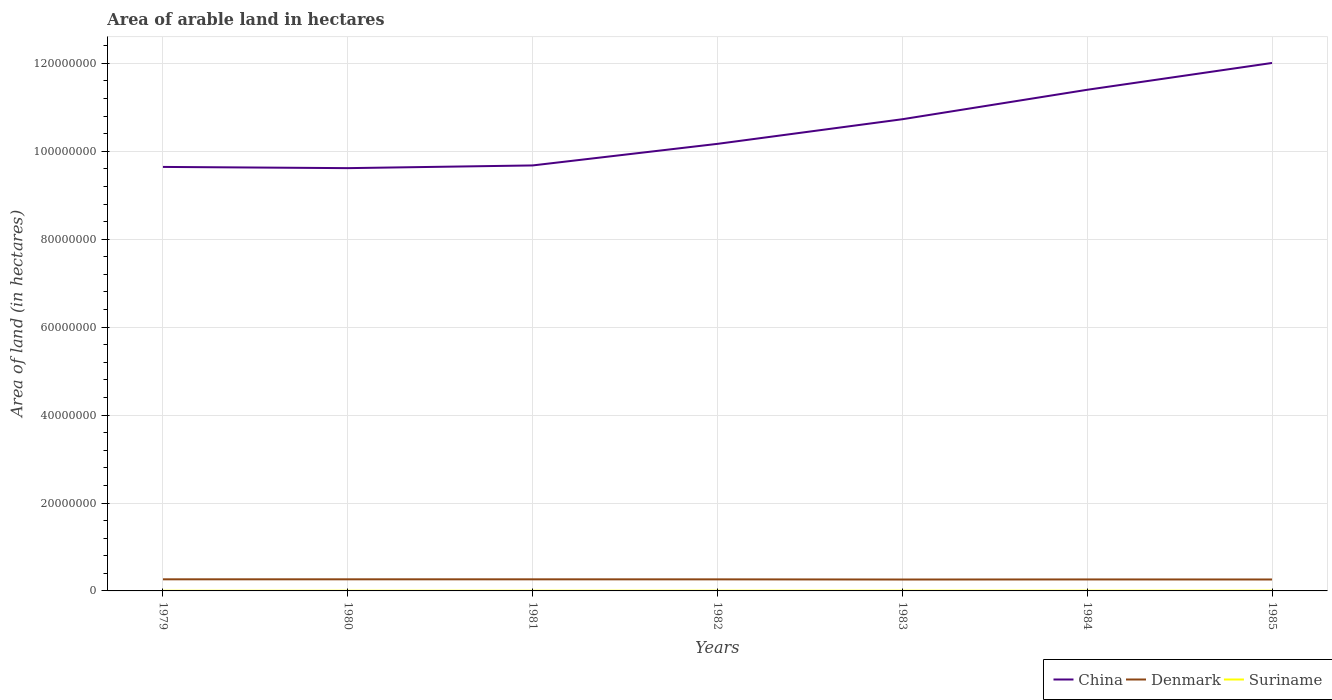How many different coloured lines are there?
Your answer should be very brief. 3. Does the line corresponding to Denmark intersect with the line corresponding to China?
Offer a very short reply. No. Is the number of lines equal to the number of legend labels?
Offer a very short reply. Yes. Across all years, what is the maximum total arable land in China?
Your answer should be very brief. 9.62e+07. What is the total total arable land in Suriname in the graph?
Offer a terse response. -5000. What is the difference between the highest and the second highest total arable land in Suriname?
Your response must be concise. 1.50e+04. Is the total arable land in Denmark strictly greater than the total arable land in Suriname over the years?
Your answer should be very brief. No. Are the values on the major ticks of Y-axis written in scientific E-notation?
Keep it short and to the point. No. Does the graph contain grids?
Provide a succinct answer. Yes. How many legend labels are there?
Offer a terse response. 3. What is the title of the graph?
Provide a short and direct response. Area of arable land in hectares. What is the label or title of the Y-axis?
Offer a terse response. Area of land (in hectares). What is the Area of land (in hectares) in China in 1979?
Provide a succinct answer. 9.65e+07. What is the Area of land (in hectares) of Denmark in 1979?
Your response must be concise. 2.64e+06. What is the Area of land (in hectares) of Suriname in 1979?
Provide a short and direct response. 3.70e+04. What is the Area of land (in hectares) of China in 1980?
Provide a short and direct response. 9.62e+07. What is the Area of land (in hectares) in Denmark in 1980?
Your response must be concise. 2.64e+06. What is the Area of land (in hectares) in China in 1981?
Your response must be concise. 9.68e+07. What is the Area of land (in hectares) of Denmark in 1981?
Give a very brief answer. 2.64e+06. What is the Area of land (in hectares) in Suriname in 1981?
Provide a short and direct response. 4.30e+04. What is the Area of land (in hectares) in China in 1982?
Offer a very short reply. 1.02e+08. What is the Area of land (in hectares) of Denmark in 1982?
Ensure brevity in your answer.  2.63e+06. What is the Area of land (in hectares) of Suriname in 1982?
Offer a very short reply. 4.60e+04. What is the Area of land (in hectares) in China in 1983?
Your answer should be very brief. 1.07e+08. What is the Area of land (in hectares) of Denmark in 1983?
Your answer should be very brief. 2.59e+06. What is the Area of land (in hectares) of Suriname in 1983?
Your answer should be very brief. 4.80e+04. What is the Area of land (in hectares) of China in 1984?
Make the answer very short. 1.14e+08. What is the Area of land (in hectares) in Denmark in 1984?
Provide a short and direct response. 2.61e+06. What is the Area of land (in hectares) of Suriname in 1984?
Offer a very short reply. 5.00e+04. What is the Area of land (in hectares) in China in 1985?
Provide a succinct answer. 1.20e+08. What is the Area of land (in hectares) of Denmark in 1985?
Offer a terse response. 2.60e+06. What is the Area of land (in hectares) of Suriname in 1985?
Offer a very short reply. 5.20e+04. Across all years, what is the maximum Area of land (in hectares) in China?
Give a very brief answer. 1.20e+08. Across all years, what is the maximum Area of land (in hectares) of Denmark?
Give a very brief answer. 2.64e+06. Across all years, what is the maximum Area of land (in hectares) of Suriname?
Your answer should be very brief. 5.20e+04. Across all years, what is the minimum Area of land (in hectares) of China?
Provide a short and direct response. 9.62e+07. Across all years, what is the minimum Area of land (in hectares) of Denmark?
Ensure brevity in your answer.  2.59e+06. Across all years, what is the minimum Area of land (in hectares) in Suriname?
Provide a succinct answer. 3.70e+04. What is the total Area of land (in hectares) in China in the graph?
Ensure brevity in your answer.  7.33e+08. What is the total Area of land (in hectares) of Denmark in the graph?
Provide a succinct answer. 1.84e+07. What is the total Area of land (in hectares) in Suriname in the graph?
Offer a very short reply. 3.16e+05. What is the difference between the Area of land (in hectares) of China in 1979 and that in 1980?
Provide a succinct answer. 2.77e+05. What is the difference between the Area of land (in hectares) in Denmark in 1979 and that in 1980?
Provide a short and direct response. 3000. What is the difference between the Area of land (in hectares) of Suriname in 1979 and that in 1980?
Provide a short and direct response. -3000. What is the difference between the Area of land (in hectares) of China in 1979 and that in 1981?
Provide a succinct answer. -3.38e+05. What is the difference between the Area of land (in hectares) in Denmark in 1979 and that in 1981?
Give a very brief answer. 5000. What is the difference between the Area of land (in hectares) of Suriname in 1979 and that in 1981?
Your answer should be very brief. -6000. What is the difference between the Area of land (in hectares) in China in 1979 and that in 1982?
Ensure brevity in your answer.  -5.25e+06. What is the difference between the Area of land (in hectares) of Denmark in 1979 and that in 1982?
Ensure brevity in your answer.  1.20e+04. What is the difference between the Area of land (in hectares) in Suriname in 1979 and that in 1982?
Offer a terse response. -9000. What is the difference between the Area of land (in hectares) of China in 1979 and that in 1983?
Ensure brevity in your answer.  -1.08e+07. What is the difference between the Area of land (in hectares) in Denmark in 1979 and that in 1983?
Ensure brevity in your answer.  4.90e+04. What is the difference between the Area of land (in hectares) of Suriname in 1979 and that in 1983?
Offer a terse response. -1.10e+04. What is the difference between the Area of land (in hectares) of China in 1979 and that in 1984?
Make the answer very short. -1.75e+07. What is the difference between the Area of land (in hectares) of Suriname in 1979 and that in 1984?
Your response must be concise. -1.30e+04. What is the difference between the Area of land (in hectares) of China in 1979 and that in 1985?
Your answer should be very brief. -2.36e+07. What is the difference between the Area of land (in hectares) of Denmark in 1979 and that in 1985?
Keep it short and to the point. 4.10e+04. What is the difference between the Area of land (in hectares) in Suriname in 1979 and that in 1985?
Give a very brief answer. -1.50e+04. What is the difference between the Area of land (in hectares) in China in 1980 and that in 1981?
Make the answer very short. -6.15e+05. What is the difference between the Area of land (in hectares) in Suriname in 1980 and that in 1981?
Your answer should be very brief. -3000. What is the difference between the Area of land (in hectares) in China in 1980 and that in 1982?
Offer a very short reply. -5.52e+06. What is the difference between the Area of land (in hectares) of Denmark in 1980 and that in 1982?
Provide a succinct answer. 9000. What is the difference between the Area of land (in hectares) in Suriname in 1980 and that in 1982?
Your response must be concise. -6000. What is the difference between the Area of land (in hectares) in China in 1980 and that in 1983?
Keep it short and to the point. -1.11e+07. What is the difference between the Area of land (in hectares) of Denmark in 1980 and that in 1983?
Your answer should be compact. 4.60e+04. What is the difference between the Area of land (in hectares) of Suriname in 1980 and that in 1983?
Keep it short and to the point. -8000. What is the difference between the Area of land (in hectares) in China in 1980 and that in 1984?
Give a very brief answer. -1.78e+07. What is the difference between the Area of land (in hectares) in Denmark in 1980 and that in 1984?
Ensure brevity in your answer.  2.70e+04. What is the difference between the Area of land (in hectares) in China in 1980 and that in 1985?
Offer a very short reply. -2.39e+07. What is the difference between the Area of land (in hectares) in Denmark in 1980 and that in 1985?
Give a very brief answer. 3.80e+04. What is the difference between the Area of land (in hectares) in Suriname in 1980 and that in 1985?
Provide a short and direct response. -1.20e+04. What is the difference between the Area of land (in hectares) of China in 1981 and that in 1982?
Your answer should be very brief. -4.91e+06. What is the difference between the Area of land (in hectares) of Denmark in 1981 and that in 1982?
Your response must be concise. 7000. What is the difference between the Area of land (in hectares) of Suriname in 1981 and that in 1982?
Keep it short and to the point. -3000. What is the difference between the Area of land (in hectares) of China in 1981 and that in 1983?
Your answer should be very brief. -1.05e+07. What is the difference between the Area of land (in hectares) in Denmark in 1981 and that in 1983?
Offer a very short reply. 4.40e+04. What is the difference between the Area of land (in hectares) of Suriname in 1981 and that in 1983?
Your answer should be very brief. -5000. What is the difference between the Area of land (in hectares) of China in 1981 and that in 1984?
Offer a terse response. -1.72e+07. What is the difference between the Area of land (in hectares) of Denmark in 1981 and that in 1984?
Keep it short and to the point. 2.50e+04. What is the difference between the Area of land (in hectares) in Suriname in 1981 and that in 1984?
Offer a very short reply. -7000. What is the difference between the Area of land (in hectares) of China in 1981 and that in 1985?
Keep it short and to the point. -2.33e+07. What is the difference between the Area of land (in hectares) of Denmark in 1981 and that in 1985?
Your answer should be very brief. 3.60e+04. What is the difference between the Area of land (in hectares) of Suriname in 1981 and that in 1985?
Give a very brief answer. -9000. What is the difference between the Area of land (in hectares) in China in 1982 and that in 1983?
Make the answer very short. -5.60e+06. What is the difference between the Area of land (in hectares) in Denmark in 1982 and that in 1983?
Make the answer very short. 3.70e+04. What is the difference between the Area of land (in hectares) in Suriname in 1982 and that in 1983?
Give a very brief answer. -2000. What is the difference between the Area of land (in hectares) in China in 1982 and that in 1984?
Provide a short and direct response. -1.23e+07. What is the difference between the Area of land (in hectares) of Denmark in 1982 and that in 1984?
Offer a terse response. 1.80e+04. What is the difference between the Area of land (in hectares) of Suriname in 1982 and that in 1984?
Ensure brevity in your answer.  -4000. What is the difference between the Area of land (in hectares) in China in 1982 and that in 1985?
Offer a very short reply. -1.84e+07. What is the difference between the Area of land (in hectares) in Denmark in 1982 and that in 1985?
Your response must be concise. 2.90e+04. What is the difference between the Area of land (in hectares) in Suriname in 1982 and that in 1985?
Provide a succinct answer. -6000. What is the difference between the Area of land (in hectares) in China in 1983 and that in 1984?
Give a very brief answer. -6.70e+06. What is the difference between the Area of land (in hectares) in Denmark in 1983 and that in 1984?
Ensure brevity in your answer.  -1.90e+04. What is the difference between the Area of land (in hectares) of Suriname in 1983 and that in 1984?
Give a very brief answer. -2000. What is the difference between the Area of land (in hectares) in China in 1983 and that in 1985?
Make the answer very short. -1.28e+07. What is the difference between the Area of land (in hectares) of Denmark in 1983 and that in 1985?
Make the answer very short. -8000. What is the difference between the Area of land (in hectares) of Suriname in 1983 and that in 1985?
Keep it short and to the point. -4000. What is the difference between the Area of land (in hectares) in China in 1984 and that in 1985?
Ensure brevity in your answer.  -6.10e+06. What is the difference between the Area of land (in hectares) of Denmark in 1984 and that in 1985?
Offer a terse response. 1.10e+04. What is the difference between the Area of land (in hectares) in Suriname in 1984 and that in 1985?
Your response must be concise. -2000. What is the difference between the Area of land (in hectares) of China in 1979 and the Area of land (in hectares) of Denmark in 1980?
Offer a very short reply. 9.38e+07. What is the difference between the Area of land (in hectares) of China in 1979 and the Area of land (in hectares) of Suriname in 1980?
Your response must be concise. 9.64e+07. What is the difference between the Area of land (in hectares) of Denmark in 1979 and the Area of land (in hectares) of Suriname in 1980?
Your answer should be very brief. 2.60e+06. What is the difference between the Area of land (in hectares) in China in 1979 and the Area of land (in hectares) in Denmark in 1981?
Offer a very short reply. 9.38e+07. What is the difference between the Area of land (in hectares) of China in 1979 and the Area of land (in hectares) of Suriname in 1981?
Make the answer very short. 9.64e+07. What is the difference between the Area of land (in hectares) of Denmark in 1979 and the Area of land (in hectares) of Suriname in 1981?
Ensure brevity in your answer.  2.60e+06. What is the difference between the Area of land (in hectares) of China in 1979 and the Area of land (in hectares) of Denmark in 1982?
Provide a short and direct response. 9.38e+07. What is the difference between the Area of land (in hectares) of China in 1979 and the Area of land (in hectares) of Suriname in 1982?
Make the answer very short. 9.64e+07. What is the difference between the Area of land (in hectares) of Denmark in 1979 and the Area of land (in hectares) of Suriname in 1982?
Provide a short and direct response. 2.60e+06. What is the difference between the Area of land (in hectares) of China in 1979 and the Area of land (in hectares) of Denmark in 1983?
Make the answer very short. 9.39e+07. What is the difference between the Area of land (in hectares) of China in 1979 and the Area of land (in hectares) of Suriname in 1983?
Your response must be concise. 9.64e+07. What is the difference between the Area of land (in hectares) in Denmark in 1979 and the Area of land (in hectares) in Suriname in 1983?
Offer a very short reply. 2.59e+06. What is the difference between the Area of land (in hectares) in China in 1979 and the Area of land (in hectares) in Denmark in 1984?
Offer a very short reply. 9.38e+07. What is the difference between the Area of land (in hectares) in China in 1979 and the Area of land (in hectares) in Suriname in 1984?
Offer a terse response. 9.64e+07. What is the difference between the Area of land (in hectares) of Denmark in 1979 and the Area of land (in hectares) of Suriname in 1984?
Provide a succinct answer. 2.59e+06. What is the difference between the Area of land (in hectares) of China in 1979 and the Area of land (in hectares) of Denmark in 1985?
Keep it short and to the point. 9.39e+07. What is the difference between the Area of land (in hectares) of China in 1979 and the Area of land (in hectares) of Suriname in 1985?
Keep it short and to the point. 9.64e+07. What is the difference between the Area of land (in hectares) of Denmark in 1979 and the Area of land (in hectares) of Suriname in 1985?
Provide a short and direct response. 2.59e+06. What is the difference between the Area of land (in hectares) of China in 1980 and the Area of land (in hectares) of Denmark in 1981?
Make the answer very short. 9.35e+07. What is the difference between the Area of land (in hectares) of China in 1980 and the Area of land (in hectares) of Suriname in 1981?
Your answer should be compact. 9.61e+07. What is the difference between the Area of land (in hectares) of Denmark in 1980 and the Area of land (in hectares) of Suriname in 1981?
Offer a terse response. 2.60e+06. What is the difference between the Area of land (in hectares) of China in 1980 and the Area of land (in hectares) of Denmark in 1982?
Your response must be concise. 9.35e+07. What is the difference between the Area of land (in hectares) in China in 1980 and the Area of land (in hectares) in Suriname in 1982?
Keep it short and to the point. 9.61e+07. What is the difference between the Area of land (in hectares) of Denmark in 1980 and the Area of land (in hectares) of Suriname in 1982?
Give a very brief answer. 2.59e+06. What is the difference between the Area of land (in hectares) in China in 1980 and the Area of land (in hectares) in Denmark in 1983?
Keep it short and to the point. 9.36e+07. What is the difference between the Area of land (in hectares) of China in 1980 and the Area of land (in hectares) of Suriname in 1983?
Offer a terse response. 9.61e+07. What is the difference between the Area of land (in hectares) in Denmark in 1980 and the Area of land (in hectares) in Suriname in 1983?
Give a very brief answer. 2.59e+06. What is the difference between the Area of land (in hectares) in China in 1980 and the Area of land (in hectares) in Denmark in 1984?
Keep it short and to the point. 9.36e+07. What is the difference between the Area of land (in hectares) of China in 1980 and the Area of land (in hectares) of Suriname in 1984?
Ensure brevity in your answer.  9.61e+07. What is the difference between the Area of land (in hectares) in Denmark in 1980 and the Area of land (in hectares) in Suriname in 1984?
Keep it short and to the point. 2.59e+06. What is the difference between the Area of land (in hectares) in China in 1980 and the Area of land (in hectares) in Denmark in 1985?
Offer a very short reply. 9.36e+07. What is the difference between the Area of land (in hectares) in China in 1980 and the Area of land (in hectares) in Suriname in 1985?
Provide a short and direct response. 9.61e+07. What is the difference between the Area of land (in hectares) of Denmark in 1980 and the Area of land (in hectares) of Suriname in 1985?
Offer a terse response. 2.59e+06. What is the difference between the Area of land (in hectares) of China in 1981 and the Area of land (in hectares) of Denmark in 1982?
Provide a succinct answer. 9.42e+07. What is the difference between the Area of land (in hectares) in China in 1981 and the Area of land (in hectares) in Suriname in 1982?
Keep it short and to the point. 9.67e+07. What is the difference between the Area of land (in hectares) of Denmark in 1981 and the Area of land (in hectares) of Suriname in 1982?
Your answer should be very brief. 2.59e+06. What is the difference between the Area of land (in hectares) of China in 1981 and the Area of land (in hectares) of Denmark in 1983?
Keep it short and to the point. 9.42e+07. What is the difference between the Area of land (in hectares) in China in 1981 and the Area of land (in hectares) in Suriname in 1983?
Your response must be concise. 9.67e+07. What is the difference between the Area of land (in hectares) in Denmark in 1981 and the Area of land (in hectares) in Suriname in 1983?
Provide a succinct answer. 2.59e+06. What is the difference between the Area of land (in hectares) of China in 1981 and the Area of land (in hectares) of Denmark in 1984?
Offer a terse response. 9.42e+07. What is the difference between the Area of land (in hectares) of China in 1981 and the Area of land (in hectares) of Suriname in 1984?
Give a very brief answer. 9.67e+07. What is the difference between the Area of land (in hectares) in Denmark in 1981 and the Area of land (in hectares) in Suriname in 1984?
Provide a short and direct response. 2.59e+06. What is the difference between the Area of land (in hectares) in China in 1981 and the Area of land (in hectares) in Denmark in 1985?
Provide a succinct answer. 9.42e+07. What is the difference between the Area of land (in hectares) in China in 1981 and the Area of land (in hectares) in Suriname in 1985?
Keep it short and to the point. 9.67e+07. What is the difference between the Area of land (in hectares) of Denmark in 1981 and the Area of land (in hectares) of Suriname in 1985?
Your answer should be compact. 2.58e+06. What is the difference between the Area of land (in hectares) of China in 1982 and the Area of land (in hectares) of Denmark in 1983?
Your response must be concise. 9.91e+07. What is the difference between the Area of land (in hectares) in China in 1982 and the Area of land (in hectares) in Suriname in 1983?
Give a very brief answer. 1.02e+08. What is the difference between the Area of land (in hectares) in Denmark in 1982 and the Area of land (in hectares) in Suriname in 1983?
Your answer should be very brief. 2.58e+06. What is the difference between the Area of land (in hectares) of China in 1982 and the Area of land (in hectares) of Denmark in 1984?
Give a very brief answer. 9.91e+07. What is the difference between the Area of land (in hectares) of China in 1982 and the Area of land (in hectares) of Suriname in 1984?
Make the answer very short. 1.02e+08. What is the difference between the Area of land (in hectares) in Denmark in 1982 and the Area of land (in hectares) in Suriname in 1984?
Offer a terse response. 2.58e+06. What is the difference between the Area of land (in hectares) of China in 1982 and the Area of land (in hectares) of Denmark in 1985?
Give a very brief answer. 9.91e+07. What is the difference between the Area of land (in hectares) in China in 1982 and the Area of land (in hectares) in Suriname in 1985?
Give a very brief answer. 1.02e+08. What is the difference between the Area of land (in hectares) of Denmark in 1982 and the Area of land (in hectares) of Suriname in 1985?
Offer a terse response. 2.58e+06. What is the difference between the Area of land (in hectares) in China in 1983 and the Area of land (in hectares) in Denmark in 1984?
Ensure brevity in your answer.  1.05e+08. What is the difference between the Area of land (in hectares) of China in 1983 and the Area of land (in hectares) of Suriname in 1984?
Offer a terse response. 1.07e+08. What is the difference between the Area of land (in hectares) of Denmark in 1983 and the Area of land (in hectares) of Suriname in 1984?
Your answer should be very brief. 2.54e+06. What is the difference between the Area of land (in hectares) in China in 1983 and the Area of land (in hectares) in Denmark in 1985?
Give a very brief answer. 1.05e+08. What is the difference between the Area of land (in hectares) in China in 1983 and the Area of land (in hectares) in Suriname in 1985?
Your response must be concise. 1.07e+08. What is the difference between the Area of land (in hectares) of Denmark in 1983 and the Area of land (in hectares) of Suriname in 1985?
Your answer should be very brief. 2.54e+06. What is the difference between the Area of land (in hectares) of China in 1984 and the Area of land (in hectares) of Denmark in 1985?
Keep it short and to the point. 1.11e+08. What is the difference between the Area of land (in hectares) of China in 1984 and the Area of land (in hectares) of Suriname in 1985?
Your answer should be compact. 1.14e+08. What is the difference between the Area of land (in hectares) in Denmark in 1984 and the Area of land (in hectares) in Suriname in 1985?
Ensure brevity in your answer.  2.56e+06. What is the average Area of land (in hectares) of China per year?
Give a very brief answer. 1.05e+08. What is the average Area of land (in hectares) of Denmark per year?
Your response must be concise. 2.62e+06. What is the average Area of land (in hectares) in Suriname per year?
Keep it short and to the point. 4.51e+04. In the year 1979, what is the difference between the Area of land (in hectares) of China and Area of land (in hectares) of Denmark?
Make the answer very short. 9.38e+07. In the year 1979, what is the difference between the Area of land (in hectares) in China and Area of land (in hectares) in Suriname?
Make the answer very short. 9.64e+07. In the year 1979, what is the difference between the Area of land (in hectares) in Denmark and Area of land (in hectares) in Suriname?
Your answer should be compact. 2.60e+06. In the year 1980, what is the difference between the Area of land (in hectares) of China and Area of land (in hectares) of Denmark?
Offer a very short reply. 9.35e+07. In the year 1980, what is the difference between the Area of land (in hectares) of China and Area of land (in hectares) of Suriname?
Provide a short and direct response. 9.61e+07. In the year 1980, what is the difference between the Area of land (in hectares) of Denmark and Area of land (in hectares) of Suriname?
Offer a very short reply. 2.60e+06. In the year 1981, what is the difference between the Area of land (in hectares) in China and Area of land (in hectares) in Denmark?
Provide a succinct answer. 9.42e+07. In the year 1981, what is the difference between the Area of land (in hectares) in China and Area of land (in hectares) in Suriname?
Your response must be concise. 9.67e+07. In the year 1981, what is the difference between the Area of land (in hectares) in Denmark and Area of land (in hectares) in Suriname?
Provide a short and direct response. 2.59e+06. In the year 1982, what is the difference between the Area of land (in hectares) in China and Area of land (in hectares) in Denmark?
Give a very brief answer. 9.91e+07. In the year 1982, what is the difference between the Area of land (in hectares) of China and Area of land (in hectares) of Suriname?
Offer a terse response. 1.02e+08. In the year 1982, what is the difference between the Area of land (in hectares) in Denmark and Area of land (in hectares) in Suriname?
Ensure brevity in your answer.  2.58e+06. In the year 1983, what is the difference between the Area of land (in hectares) in China and Area of land (in hectares) in Denmark?
Provide a succinct answer. 1.05e+08. In the year 1983, what is the difference between the Area of land (in hectares) of China and Area of land (in hectares) of Suriname?
Ensure brevity in your answer.  1.07e+08. In the year 1983, what is the difference between the Area of land (in hectares) in Denmark and Area of land (in hectares) in Suriname?
Your answer should be very brief. 2.54e+06. In the year 1984, what is the difference between the Area of land (in hectares) in China and Area of land (in hectares) in Denmark?
Your answer should be very brief. 1.11e+08. In the year 1984, what is the difference between the Area of land (in hectares) in China and Area of land (in hectares) in Suriname?
Your answer should be very brief. 1.14e+08. In the year 1984, what is the difference between the Area of land (in hectares) in Denmark and Area of land (in hectares) in Suriname?
Ensure brevity in your answer.  2.56e+06. In the year 1985, what is the difference between the Area of land (in hectares) of China and Area of land (in hectares) of Denmark?
Offer a terse response. 1.17e+08. In the year 1985, what is the difference between the Area of land (in hectares) of China and Area of land (in hectares) of Suriname?
Offer a very short reply. 1.20e+08. In the year 1985, what is the difference between the Area of land (in hectares) in Denmark and Area of land (in hectares) in Suriname?
Your answer should be very brief. 2.55e+06. What is the ratio of the Area of land (in hectares) of Denmark in 1979 to that in 1980?
Keep it short and to the point. 1. What is the ratio of the Area of land (in hectares) of Suriname in 1979 to that in 1980?
Provide a succinct answer. 0.93. What is the ratio of the Area of land (in hectares) in China in 1979 to that in 1981?
Give a very brief answer. 1. What is the ratio of the Area of land (in hectares) of Denmark in 1979 to that in 1981?
Provide a succinct answer. 1. What is the ratio of the Area of land (in hectares) in Suriname in 1979 to that in 1981?
Your answer should be compact. 0.86. What is the ratio of the Area of land (in hectares) of China in 1979 to that in 1982?
Provide a short and direct response. 0.95. What is the ratio of the Area of land (in hectares) in Denmark in 1979 to that in 1982?
Keep it short and to the point. 1. What is the ratio of the Area of land (in hectares) in Suriname in 1979 to that in 1982?
Provide a succinct answer. 0.8. What is the ratio of the Area of land (in hectares) of China in 1979 to that in 1983?
Your answer should be compact. 0.9. What is the ratio of the Area of land (in hectares) of Denmark in 1979 to that in 1983?
Ensure brevity in your answer.  1.02. What is the ratio of the Area of land (in hectares) in Suriname in 1979 to that in 1983?
Offer a terse response. 0.77. What is the ratio of the Area of land (in hectares) in China in 1979 to that in 1984?
Offer a terse response. 0.85. What is the ratio of the Area of land (in hectares) in Denmark in 1979 to that in 1984?
Your response must be concise. 1.01. What is the ratio of the Area of land (in hectares) of Suriname in 1979 to that in 1984?
Keep it short and to the point. 0.74. What is the ratio of the Area of land (in hectares) of China in 1979 to that in 1985?
Provide a succinct answer. 0.8. What is the ratio of the Area of land (in hectares) in Denmark in 1979 to that in 1985?
Offer a terse response. 1.02. What is the ratio of the Area of land (in hectares) of Suriname in 1979 to that in 1985?
Give a very brief answer. 0.71. What is the ratio of the Area of land (in hectares) of China in 1980 to that in 1981?
Keep it short and to the point. 0.99. What is the ratio of the Area of land (in hectares) in Denmark in 1980 to that in 1981?
Ensure brevity in your answer.  1. What is the ratio of the Area of land (in hectares) of Suriname in 1980 to that in 1981?
Give a very brief answer. 0.93. What is the ratio of the Area of land (in hectares) in China in 1980 to that in 1982?
Make the answer very short. 0.95. What is the ratio of the Area of land (in hectares) of Denmark in 1980 to that in 1982?
Ensure brevity in your answer.  1. What is the ratio of the Area of land (in hectares) of Suriname in 1980 to that in 1982?
Make the answer very short. 0.87. What is the ratio of the Area of land (in hectares) of China in 1980 to that in 1983?
Ensure brevity in your answer.  0.9. What is the ratio of the Area of land (in hectares) of Denmark in 1980 to that in 1983?
Offer a terse response. 1.02. What is the ratio of the Area of land (in hectares) of Suriname in 1980 to that in 1983?
Make the answer very short. 0.83. What is the ratio of the Area of land (in hectares) in China in 1980 to that in 1984?
Your response must be concise. 0.84. What is the ratio of the Area of land (in hectares) in Denmark in 1980 to that in 1984?
Your response must be concise. 1.01. What is the ratio of the Area of land (in hectares) in Suriname in 1980 to that in 1984?
Your answer should be very brief. 0.8. What is the ratio of the Area of land (in hectares) in China in 1980 to that in 1985?
Your response must be concise. 0.8. What is the ratio of the Area of land (in hectares) of Denmark in 1980 to that in 1985?
Offer a very short reply. 1.01. What is the ratio of the Area of land (in hectares) of Suriname in 1980 to that in 1985?
Provide a succinct answer. 0.77. What is the ratio of the Area of land (in hectares) in China in 1981 to that in 1982?
Give a very brief answer. 0.95. What is the ratio of the Area of land (in hectares) of Suriname in 1981 to that in 1982?
Your response must be concise. 0.93. What is the ratio of the Area of land (in hectares) of China in 1981 to that in 1983?
Your answer should be very brief. 0.9. What is the ratio of the Area of land (in hectares) in Denmark in 1981 to that in 1983?
Your response must be concise. 1.02. What is the ratio of the Area of land (in hectares) in Suriname in 1981 to that in 1983?
Offer a very short reply. 0.9. What is the ratio of the Area of land (in hectares) of China in 1981 to that in 1984?
Make the answer very short. 0.85. What is the ratio of the Area of land (in hectares) in Denmark in 1981 to that in 1984?
Offer a very short reply. 1.01. What is the ratio of the Area of land (in hectares) in Suriname in 1981 to that in 1984?
Your response must be concise. 0.86. What is the ratio of the Area of land (in hectares) in China in 1981 to that in 1985?
Offer a terse response. 0.81. What is the ratio of the Area of land (in hectares) in Denmark in 1981 to that in 1985?
Your response must be concise. 1.01. What is the ratio of the Area of land (in hectares) of Suriname in 1981 to that in 1985?
Your answer should be very brief. 0.83. What is the ratio of the Area of land (in hectares) in China in 1982 to that in 1983?
Provide a succinct answer. 0.95. What is the ratio of the Area of land (in hectares) of Denmark in 1982 to that in 1983?
Your answer should be compact. 1.01. What is the ratio of the Area of land (in hectares) of China in 1982 to that in 1984?
Make the answer very short. 0.89. What is the ratio of the Area of land (in hectares) in Suriname in 1982 to that in 1984?
Your answer should be compact. 0.92. What is the ratio of the Area of land (in hectares) of China in 1982 to that in 1985?
Offer a very short reply. 0.85. What is the ratio of the Area of land (in hectares) in Denmark in 1982 to that in 1985?
Your response must be concise. 1.01. What is the ratio of the Area of land (in hectares) in Suriname in 1982 to that in 1985?
Your answer should be compact. 0.88. What is the ratio of the Area of land (in hectares) of China in 1983 to that in 1984?
Keep it short and to the point. 0.94. What is the ratio of the Area of land (in hectares) of Denmark in 1983 to that in 1984?
Your answer should be compact. 0.99. What is the ratio of the Area of land (in hectares) of Suriname in 1983 to that in 1984?
Your response must be concise. 0.96. What is the ratio of the Area of land (in hectares) in China in 1983 to that in 1985?
Keep it short and to the point. 0.89. What is the ratio of the Area of land (in hectares) in Suriname in 1983 to that in 1985?
Offer a terse response. 0.92. What is the ratio of the Area of land (in hectares) of China in 1984 to that in 1985?
Keep it short and to the point. 0.95. What is the ratio of the Area of land (in hectares) in Suriname in 1984 to that in 1985?
Keep it short and to the point. 0.96. What is the difference between the highest and the second highest Area of land (in hectares) of China?
Keep it short and to the point. 6.10e+06. What is the difference between the highest and the second highest Area of land (in hectares) in Denmark?
Offer a terse response. 3000. What is the difference between the highest and the lowest Area of land (in hectares) of China?
Offer a terse response. 2.39e+07. What is the difference between the highest and the lowest Area of land (in hectares) of Denmark?
Make the answer very short. 4.90e+04. What is the difference between the highest and the lowest Area of land (in hectares) in Suriname?
Offer a terse response. 1.50e+04. 